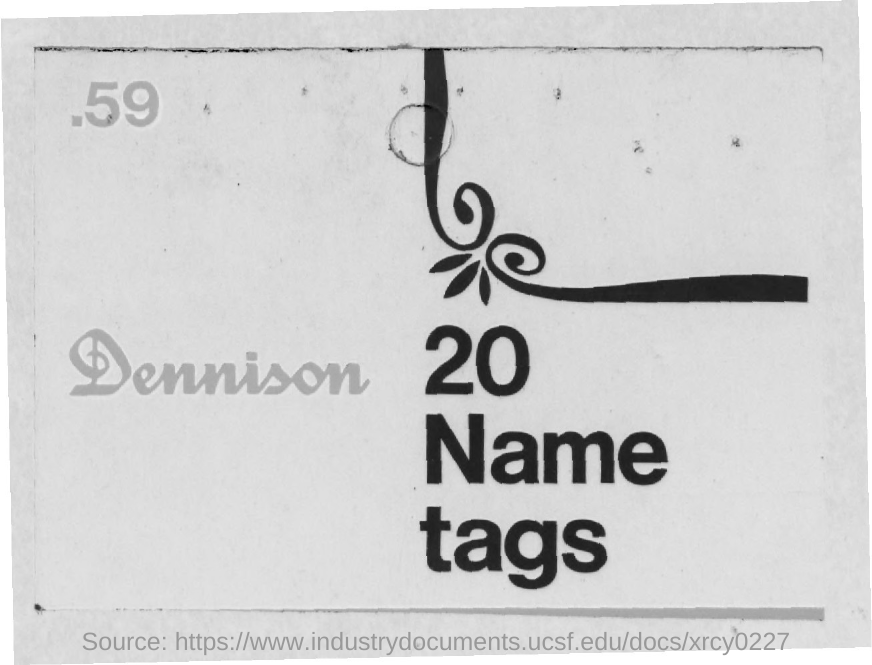What is the number given at the left top corner of the page?
Provide a short and direct response. 59. How many "Name tags" are mentioned?
Provide a succinct answer. 20. What is written to the left side of "20 Name tags"?
Provide a succinct answer. Dennison. 